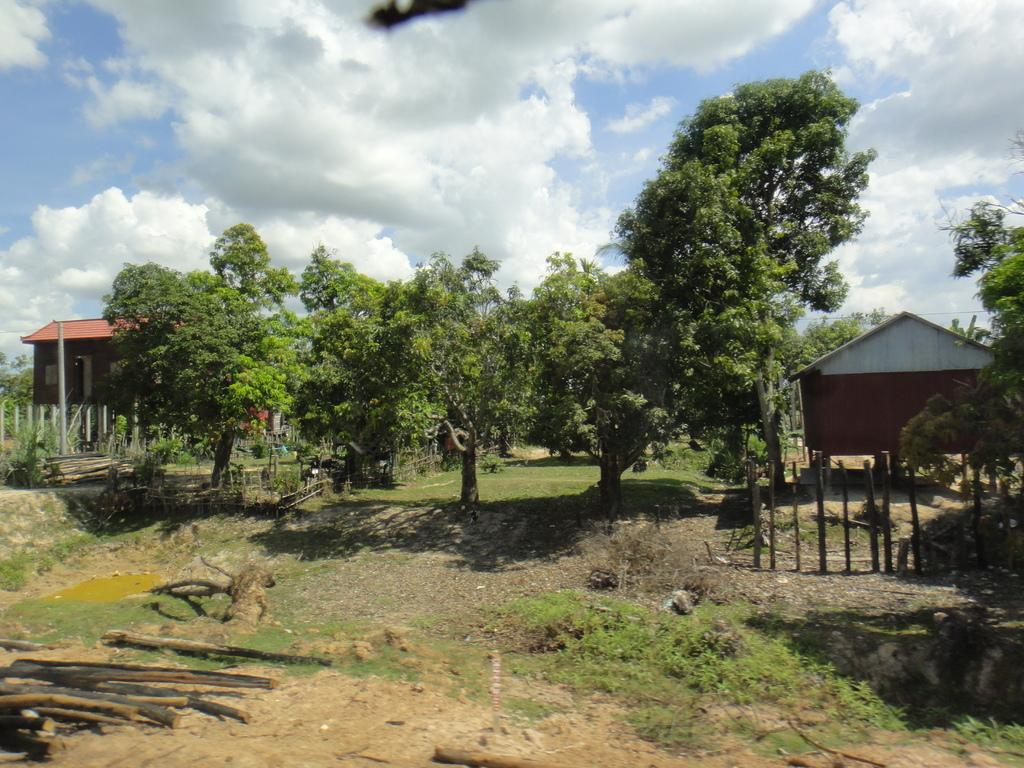What type of vegetation is present in the image? There are trees in the ground. What structure can be seen on the right side of the image? There is an iron shed tent on the right side. What is the color of the house in the background? The house in the background is brown. What material is used for the roof of the house? The roof top of the house has red tiles. Where is the cushion placed in the image? There is no cushion present in the image. What type of spot can be seen on the roof of the house? There is no spot visible on the roof of the house; it has red tiles. 